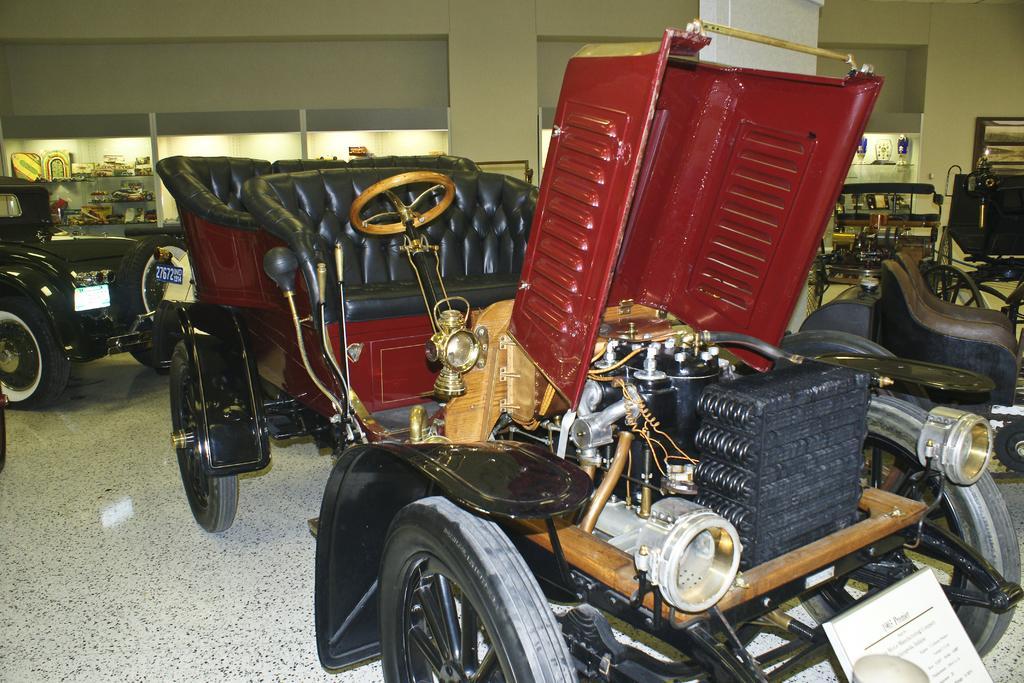In one or two sentences, can you explain what this image depicts? In this image I can see a car which is black, maroon, gold and white in color is on the white colored floor. In the background I can see few other vehicles on the floor, the wall, few racks, few lights and few objects in the racks. 